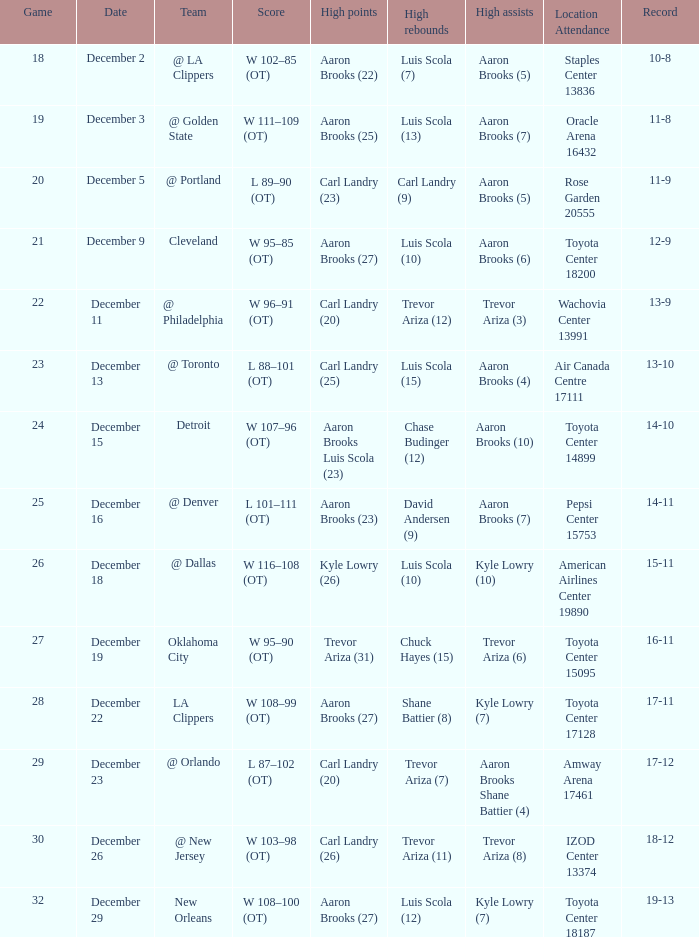Would you mind parsing the complete table? {'header': ['Game', 'Date', 'Team', 'Score', 'High points', 'High rebounds', 'High assists', 'Location Attendance', 'Record'], 'rows': [['18', 'December 2', '@ LA Clippers', 'W 102–85 (OT)', 'Aaron Brooks (22)', 'Luis Scola (7)', 'Aaron Brooks (5)', 'Staples Center 13836', '10-8'], ['19', 'December 3', '@ Golden State', 'W 111–109 (OT)', 'Aaron Brooks (25)', 'Luis Scola (13)', 'Aaron Brooks (7)', 'Oracle Arena 16432', '11-8'], ['20', 'December 5', '@ Portland', 'L 89–90 (OT)', 'Carl Landry (23)', 'Carl Landry (9)', 'Aaron Brooks (5)', 'Rose Garden 20555', '11-9'], ['21', 'December 9', 'Cleveland', 'W 95–85 (OT)', 'Aaron Brooks (27)', 'Luis Scola (10)', 'Aaron Brooks (6)', 'Toyota Center 18200', '12-9'], ['22', 'December 11', '@ Philadelphia', 'W 96–91 (OT)', 'Carl Landry (20)', 'Trevor Ariza (12)', 'Trevor Ariza (3)', 'Wachovia Center 13991', '13-9'], ['23', 'December 13', '@ Toronto', 'L 88–101 (OT)', 'Carl Landry (25)', 'Luis Scola (15)', 'Aaron Brooks (4)', 'Air Canada Centre 17111', '13-10'], ['24', 'December 15', 'Detroit', 'W 107–96 (OT)', 'Aaron Brooks Luis Scola (23)', 'Chase Budinger (12)', 'Aaron Brooks (10)', 'Toyota Center 14899', '14-10'], ['25', 'December 16', '@ Denver', 'L 101–111 (OT)', 'Aaron Brooks (23)', 'David Andersen (9)', 'Aaron Brooks (7)', 'Pepsi Center 15753', '14-11'], ['26', 'December 18', '@ Dallas', 'W 116–108 (OT)', 'Kyle Lowry (26)', 'Luis Scola (10)', 'Kyle Lowry (10)', 'American Airlines Center 19890', '15-11'], ['27', 'December 19', 'Oklahoma City', 'W 95–90 (OT)', 'Trevor Ariza (31)', 'Chuck Hayes (15)', 'Trevor Ariza (6)', 'Toyota Center 15095', '16-11'], ['28', 'December 22', 'LA Clippers', 'W 108–99 (OT)', 'Aaron Brooks (27)', 'Shane Battier (8)', 'Kyle Lowry (7)', 'Toyota Center 17128', '17-11'], ['29', 'December 23', '@ Orlando', 'L 87–102 (OT)', 'Carl Landry (20)', 'Trevor Ariza (7)', 'Aaron Brooks Shane Battier (4)', 'Amway Arena 17461', '17-12'], ['30', 'December 26', '@ New Jersey', 'W 103–98 (OT)', 'Carl Landry (26)', 'Trevor Ariza (11)', 'Trevor Ariza (8)', 'IZOD Center 13374', '18-12'], ['32', 'December 29', 'New Orleans', 'W 108–100 (OT)', 'Aaron Brooks (27)', 'Luis Scola (12)', 'Kyle Lowry (7)', 'Toyota Center 18187', '19-13']]} Who did the high rebounds in the game where Carl Landry (23) did the most high points? Carl Landry (9). 